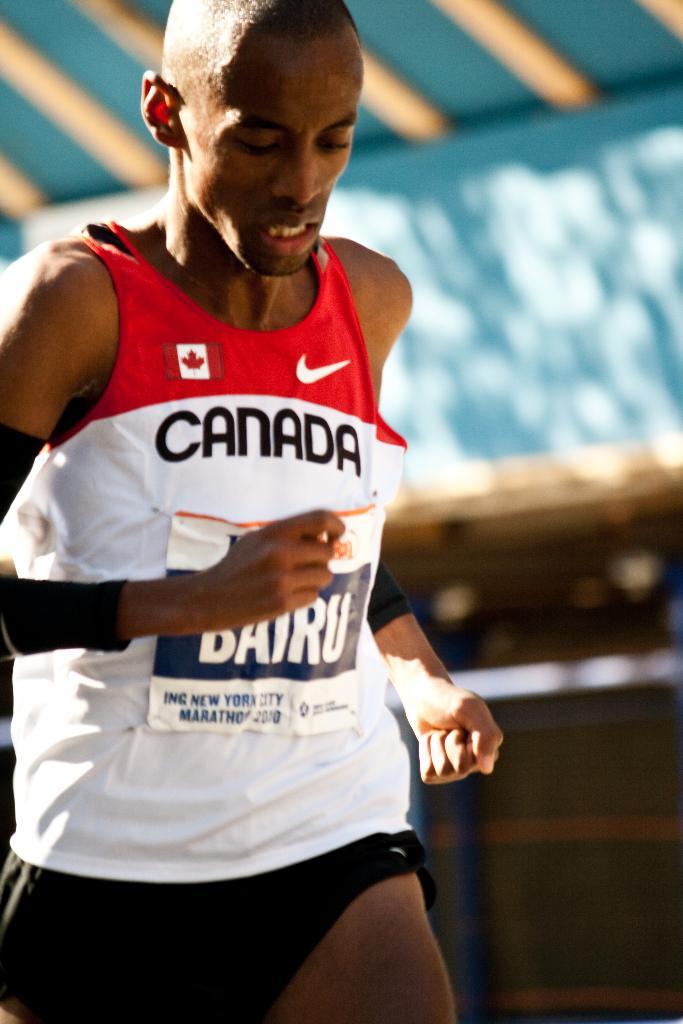What country is the runner from?
Your answer should be compact. Canada. Is this runner from canada?
Make the answer very short. Yes. 